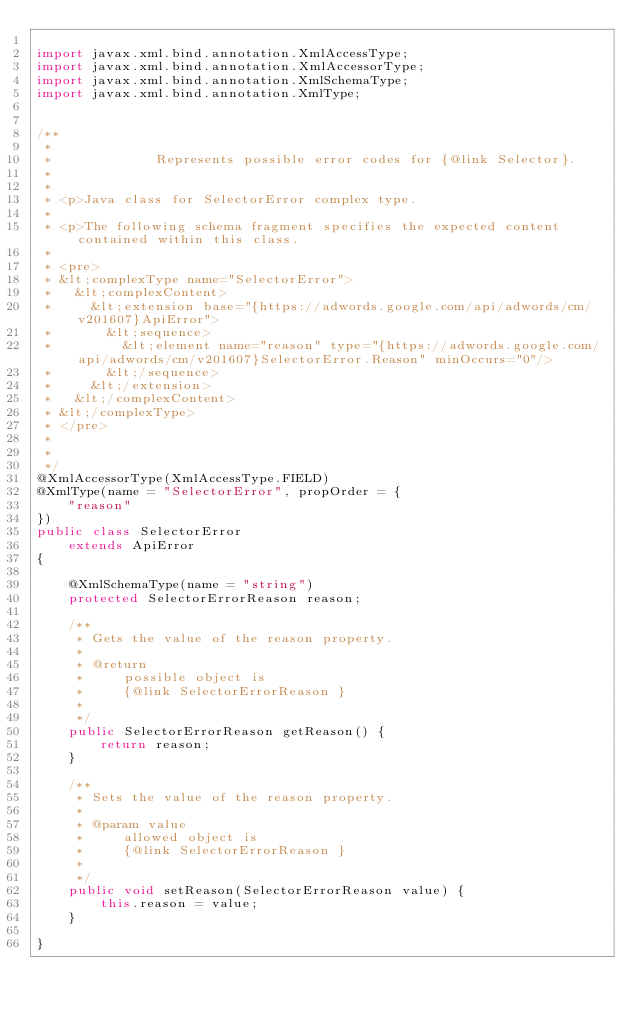<code> <loc_0><loc_0><loc_500><loc_500><_Java_>
import javax.xml.bind.annotation.XmlAccessType;
import javax.xml.bind.annotation.XmlAccessorType;
import javax.xml.bind.annotation.XmlSchemaType;
import javax.xml.bind.annotation.XmlType;


/**
 * 
 *             Represents possible error codes for {@link Selector}.
 *           
 * 
 * <p>Java class for SelectorError complex type.
 * 
 * <p>The following schema fragment specifies the expected content contained within this class.
 * 
 * <pre>
 * &lt;complexType name="SelectorError">
 *   &lt;complexContent>
 *     &lt;extension base="{https://adwords.google.com/api/adwords/cm/v201607}ApiError">
 *       &lt;sequence>
 *         &lt;element name="reason" type="{https://adwords.google.com/api/adwords/cm/v201607}SelectorError.Reason" minOccurs="0"/>
 *       &lt;/sequence>
 *     &lt;/extension>
 *   &lt;/complexContent>
 * &lt;/complexType>
 * </pre>
 * 
 * 
 */
@XmlAccessorType(XmlAccessType.FIELD)
@XmlType(name = "SelectorError", propOrder = {
    "reason"
})
public class SelectorError
    extends ApiError
{

    @XmlSchemaType(name = "string")
    protected SelectorErrorReason reason;

    /**
     * Gets the value of the reason property.
     * 
     * @return
     *     possible object is
     *     {@link SelectorErrorReason }
     *     
     */
    public SelectorErrorReason getReason() {
        return reason;
    }

    /**
     * Sets the value of the reason property.
     * 
     * @param value
     *     allowed object is
     *     {@link SelectorErrorReason }
     *     
     */
    public void setReason(SelectorErrorReason value) {
        this.reason = value;
    }

}
</code> 